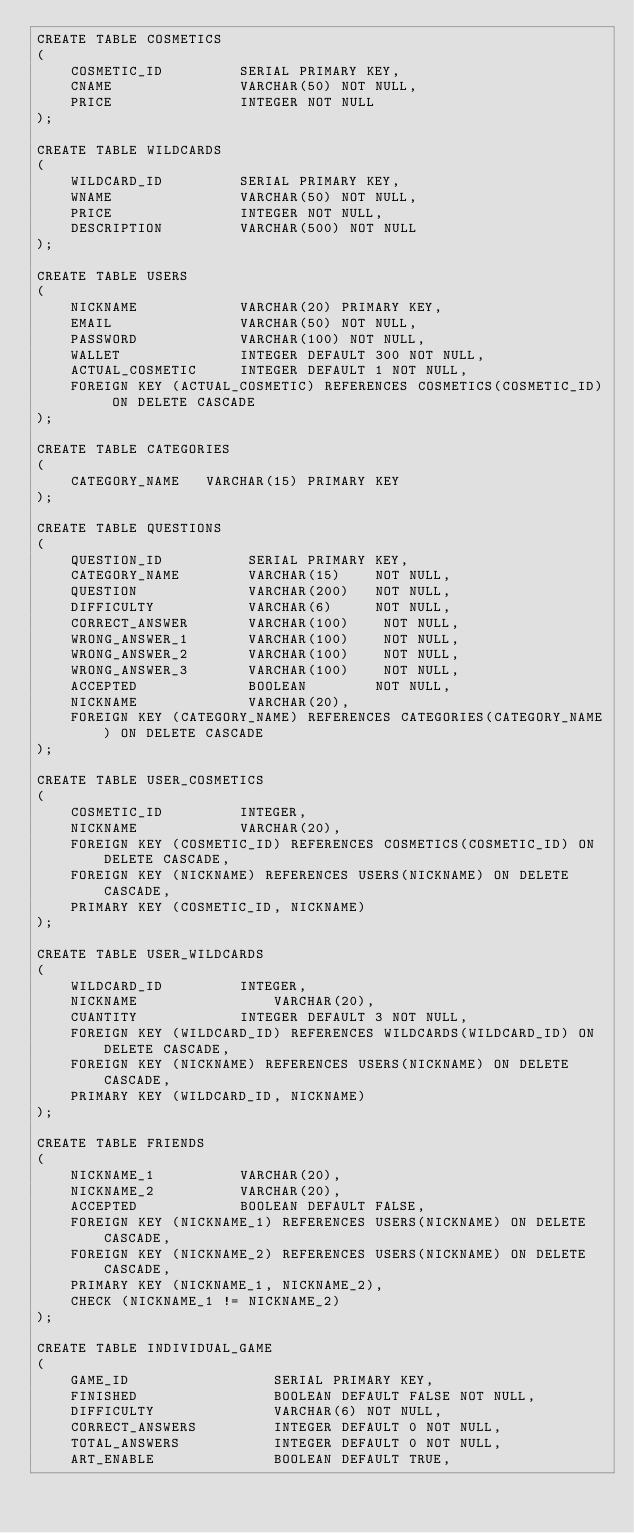<code> <loc_0><loc_0><loc_500><loc_500><_SQL_>CREATE TABLE COSMETICS
(
	COSMETIC_ID			SERIAL PRIMARY KEY,
    CNAME               VARCHAR(50) NOT NULL,
	PRICE				INTEGER NOT NULL
);

CREATE TABLE WILDCARDS
(
	WILDCARD_ID			SERIAL PRIMARY KEY,
    WNAME               VARCHAR(50) NOT NULL,
	PRICE				INTEGER NOT NULL,
	DESCRIPTION			VARCHAR(500) NOT NULL
);

CREATE TABLE USERS
(
	NICKNAME			VARCHAR(20) PRIMARY KEY,
	EMAIL				VARCHAR(50) NOT NULL,
	PASSWORD			VARCHAR(100) NOT NULL,
	WALLET				INTEGER DEFAULT 300 NOT NULL,
	ACTUAL_COSMETIC		INTEGER DEFAULT 1 NOT NULL,
	FOREIGN KEY (ACTUAL_COSMETIC) REFERENCES COSMETICS(COSMETIC_ID) ON DELETE CASCADE
);

CREATE TABLE CATEGORIES
(
    CATEGORY_NAME   VARCHAR(15) PRIMARY KEY
);

CREATE TABLE QUESTIONS
(
    QUESTION_ID          SERIAL PRIMARY KEY,
    CATEGORY_NAME        VARCHAR(15)    NOT NULL,
    QUESTION             VARCHAR(200)   NOT NULL,
	DIFFICULTY			 VARCHAR(6)		NOT NULL,
    CORRECT_ANSWER       VARCHAR(100)    NOT NULL,
    WRONG_ANSWER_1   	 VARCHAR(100)    NOT NULL,
    WRONG_ANSWER_2   	 VARCHAR(100)    NOT NULL,
    WRONG_ANSWER_3   	 VARCHAR(100)    NOT NULL,
	ACCEPTED			 BOOLEAN		NOT NULL,
	NICKNAME			 VARCHAR(20),
    FOREIGN KEY (CATEGORY_NAME) REFERENCES CATEGORIES(CATEGORY_NAME) ON DELETE CASCADE
);

CREATE TABLE USER_COSMETICS
(
	COSMETIC_ID 		INTEGER,
	NICKNAME			VARCHAR(20),
	FOREIGN KEY (COSMETIC_ID) REFERENCES COSMETICS(COSMETIC_ID) ON DELETE CASCADE,
	FOREIGN KEY (NICKNAME) REFERENCES USERS(NICKNAME) ON DELETE CASCADE,
	PRIMARY KEY (COSMETIC_ID, NICKNAME)
);

CREATE TABLE USER_WILDCARDS
(
	WILDCARD_ID 		INTEGER,
	NICKNAME				VARCHAR(20),
	CUANTITY			INTEGER DEFAULT 3 NOT NULL,
	FOREIGN KEY (WILDCARD_ID) REFERENCES WILDCARDS(WILDCARD_ID) ON DELETE CASCADE,
	FOREIGN KEY (NICKNAME) REFERENCES USERS(NICKNAME) ON DELETE CASCADE,
	PRIMARY KEY (WILDCARD_ID, NICKNAME)
);

CREATE TABLE FRIENDS
(
	NICKNAME_1 			VARCHAR(20),
	NICKNAME_2			VARCHAR(20),
	ACCEPTED			BOOLEAN DEFAULT FALSE,
	FOREIGN KEY (NICKNAME_1) REFERENCES USERS(NICKNAME) ON DELETE CASCADE,
	FOREIGN KEY (NICKNAME_2) REFERENCES USERS(NICKNAME) ON DELETE CASCADE,
	PRIMARY KEY (NICKNAME_1, NICKNAME_2),
	CHECK (NICKNAME_1 != NICKNAME_2)
);

CREATE TABLE INDIVIDUAL_GAME
(
	GAME_ID					SERIAL PRIMARY KEY,
	FINISHED				BOOLEAN DEFAULT FALSE NOT NULL,
	DIFFICULTY				VARCHAR(6) NOT NULL,
	CORRECT_ANSWERS			INTEGER DEFAULT 0 NOT NULL,
	TOTAL_ANSWERS			INTEGER DEFAULT 0 NOT NULL,
	ART_ENABLE				BOOLEAN DEFAULT TRUE,</code> 